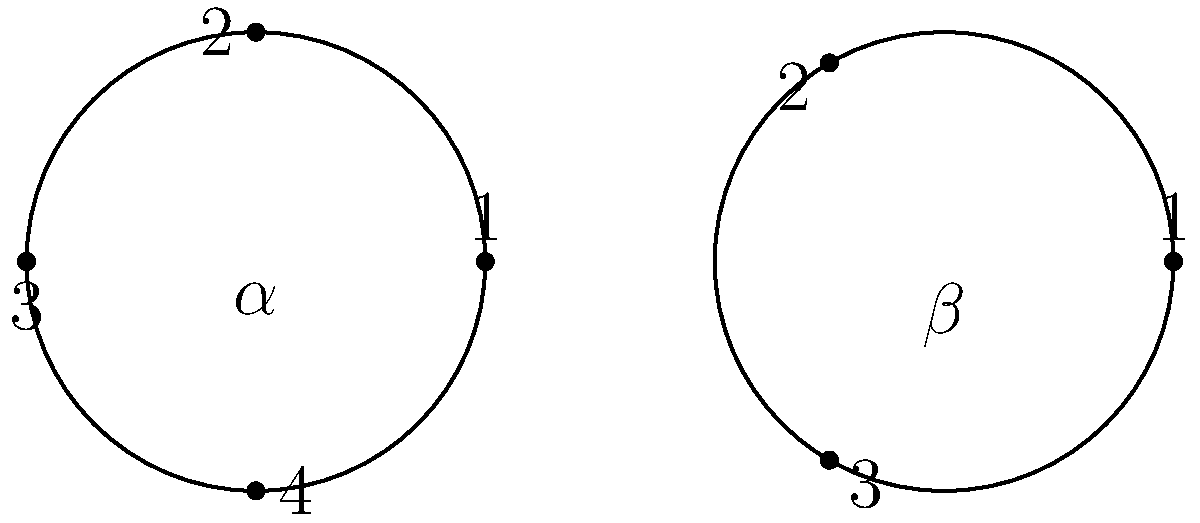Given the permutations $\alpha = (1 \, 2 \, 3 \, 4)$ and $\beta = (1 \, 2 \, 3)$ in cycle notation, determine the composition $\alpha \circ \beta$ (first apply $\beta$, then $\alpha$) and express the result in cycle notation. Let's approach this step-by-step:

1) First, we apply $\beta$:
   $\beta: 1 \to 2, 2 \to 3, 3 \to 1, 4 \to 4$

2) Then, we apply $\alpha$ to the result:
   For 1: $\beta(1) = 2$, then $\alpha(2) = 3$
   For 2: $\beta(2) = 3$, then $\alpha(3) = 4$
   For 3: $\beta(3) = 1$, then $\alpha(1) = 2$
   For 4: $\beta(4) = 4$, then $\alpha(4) = 1$

3) So, the overall mapping is:
   $1 \to 3$
   $2 \to 4$
   $3 \to 2$
   $4 \to 1$

4) We can write this in cycle notation by starting with any number and following the mapping until we return to the starting number:
   Start with 1: $1 \to 3 \to 2 \to 4 \to 1$

5) This forms a single 4-cycle.

Therefore, $\alpha \circ \beta = (1 \, 3 \, 2 \, 4)$.
Answer: $(1 \, 3 \, 2 \, 4)$ 